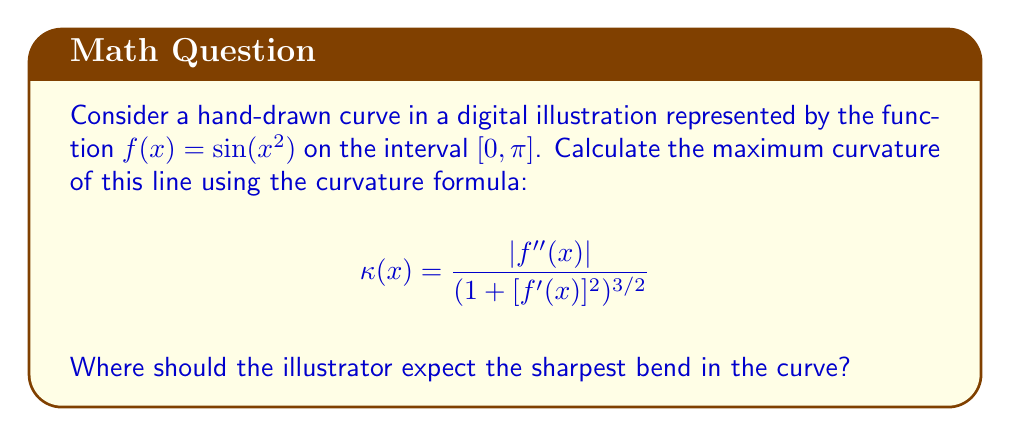Solve this math problem. To find the maximum curvature, we need to follow these steps:

1) First, let's calculate $f'(x)$ and $f''(x)$:
   $f'(x) = 2x \cos(x^2)$
   $f''(x) = 2\cos(x^2) - 4x^2 \sin(x^2)$

2) Now, let's substitute these into the curvature formula:
   $$ \kappa(x) = \frac{|2\cos(x^2) - 4x^2 \sin(x^2)|}{(1 + [2x \cos(x^2)]^2)^{3/2}} $$

3) To find the maximum curvature, we need to find where $\frac{d}{dx}\kappa(x) = 0$. However, this is a complex expression and solving it analytically is challenging.

4) Instead, we can observe that the numerator will be largest when $x$ is close to 0 (as $\cos(0) = 1$ and $\sin(0) = 0$), and the denominator will be smallest when $x$ is close to 0 (as $\cos(0) = 1$).

5) Therefore, the maximum curvature will occur very close to $x = 0$.

6) As $x$ approaches 0, the curvature approaches:
   $$ \lim_{x \to 0} \kappa(x) = \frac{|2|}{(1 + 0)^{3/2}} = 2 $$

Thus, the maximum curvature is 2, occurring at $x = 0$.
Answer: Maximum curvature = 2, at $x = 0$ 